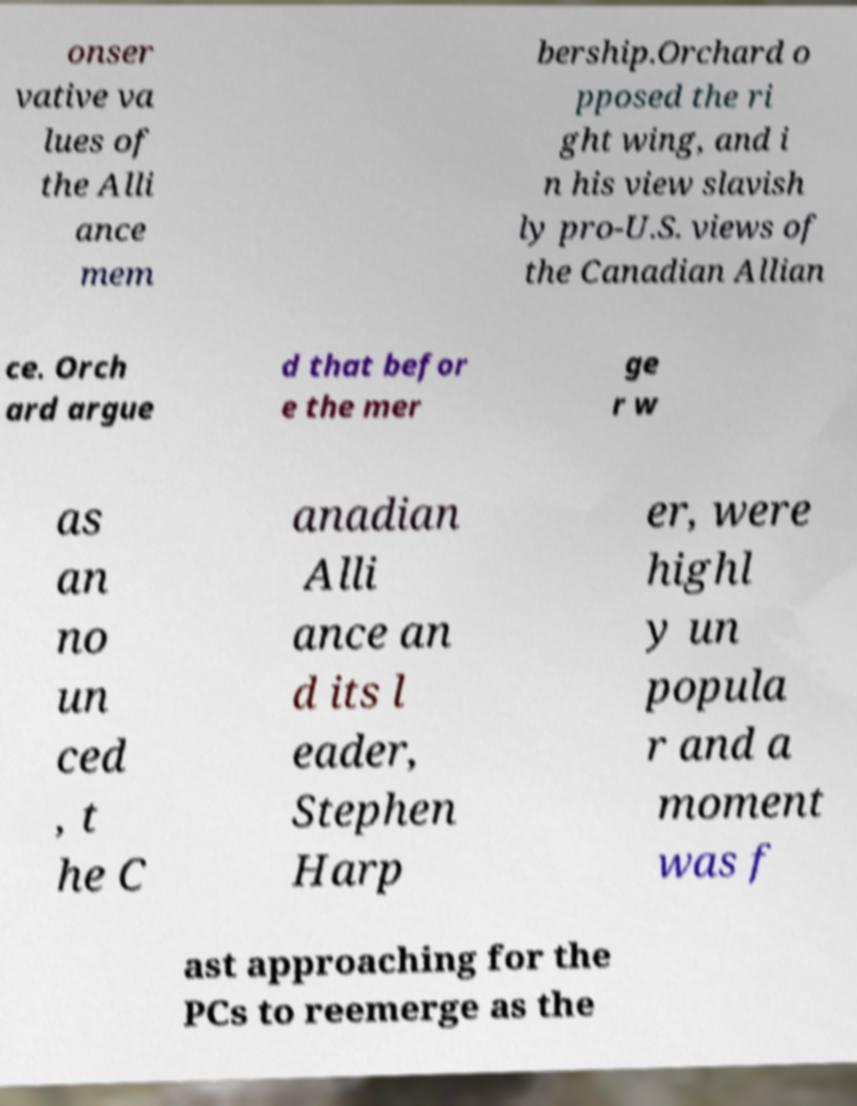Could you assist in decoding the text presented in this image and type it out clearly? onser vative va lues of the Alli ance mem bership.Orchard o pposed the ri ght wing, and i n his view slavish ly pro-U.S. views of the Canadian Allian ce. Orch ard argue d that befor e the mer ge r w as an no un ced , t he C anadian Alli ance an d its l eader, Stephen Harp er, were highl y un popula r and a moment was f ast approaching for the PCs to reemerge as the 